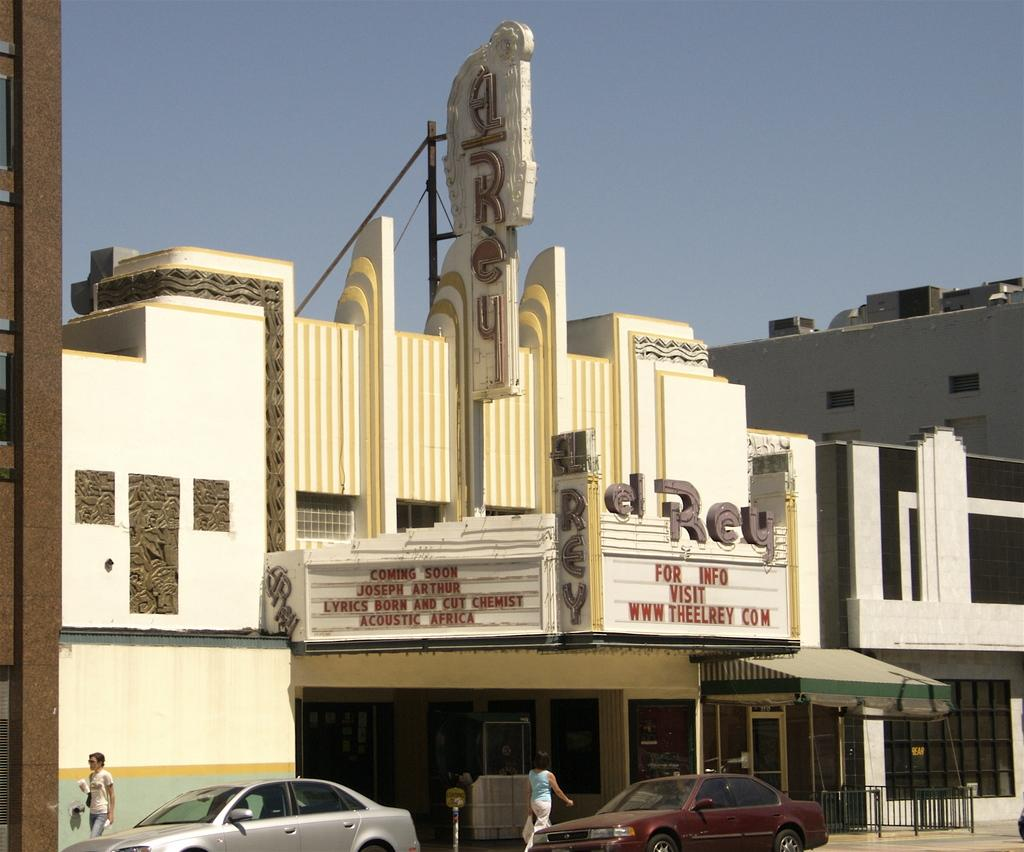What type of vehicles can be seen on the road in the image? There are cars on the road in the image. Are there any people present on the road in the image? Yes, there are people on the road in the image. What structures can be seen in the background of the image? There are buildings visible in the image. What type of fruit is being used as an ornament on the cars in the image? There is no fruit or ornament present on the cars in the image. What type of pie is being served to the people on the road in the image? There is no pie present in the image; it features cars, people, and buildings. 